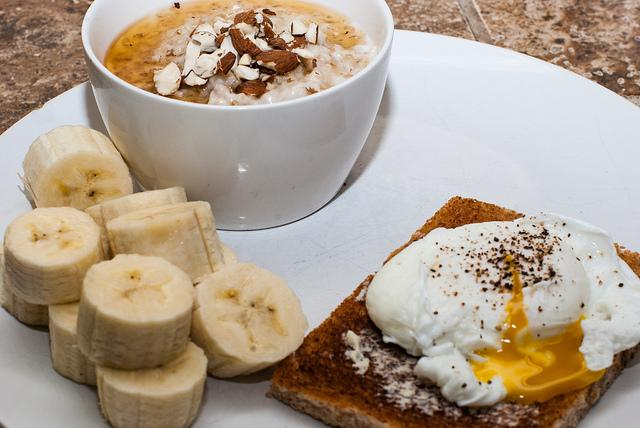What is this style of egg called?

Choices:
A) soft boiled
B) scrambled
C) hard boiled
D) poached poached 